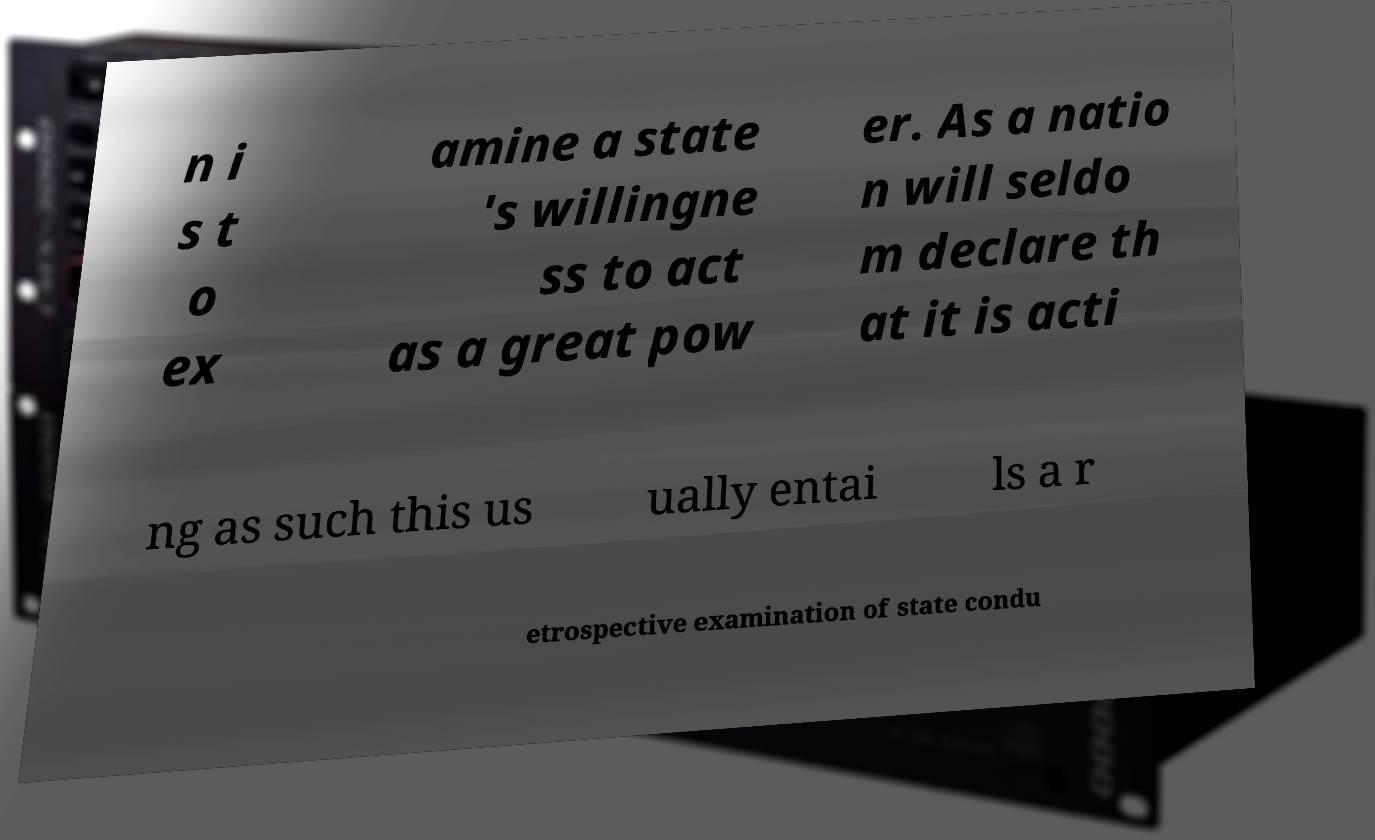Please read and relay the text visible in this image. What does it say? n i s t o ex amine a state 's willingne ss to act as a great pow er. As a natio n will seldo m declare th at it is acti ng as such this us ually entai ls a r etrospective examination of state condu 